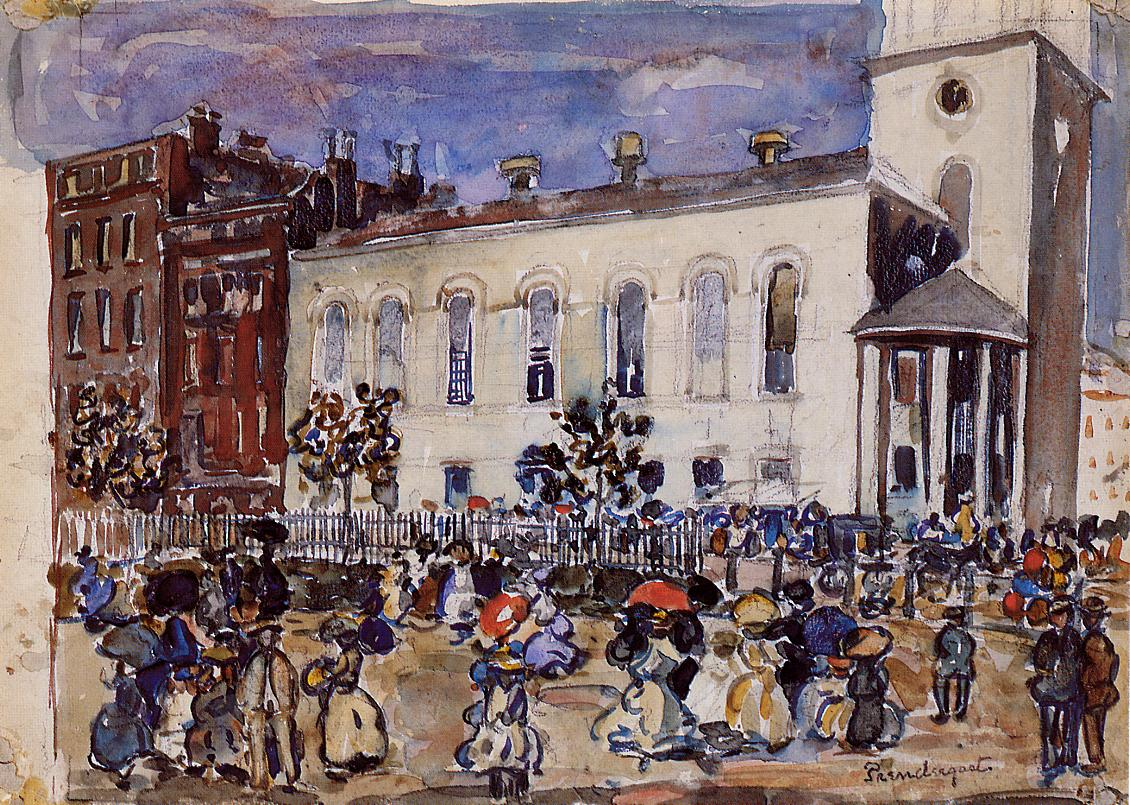Can you elaborate on the elements of the picture provided? The image is a masterful impressionist portrayal of a vibrant street scene. The painting employs a loose, dynamic brushstroke technique that infuses the canvas with life, suggesting movement and interaction among the figures. Characters dressed in the distinct garb of the early 20th century populate the scene, with some walking briskly, others conversing, and children playing. These figures are painted in a range of deep blues, muted yellows, and vibrant whites, which stand out against the softer earth tones and sky's blues. Prominently, a historical building adorned with Classical architectural motifs anchors the composition in the background, its faded white façade and tall, striking tower adding a sense of permanence to the otherwise fluid scene. This technique not only emphasizes the ephemeral nature of day-to-day activities but also contrasts with the enduring nature of the built environment. 